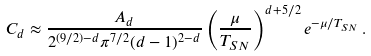Convert formula to latex. <formula><loc_0><loc_0><loc_500><loc_500>C _ { d } \approx \frac { A _ { d } } { 2 ^ { ( 9 / 2 ) - d } \pi ^ { 7 / 2 } ( d - 1 ) ^ { 2 - d } } \left ( \frac { \mu } { T _ { S N } } \right ) ^ { d + 5 / 2 } e ^ { - \mu / T _ { S N } } \, .</formula> 